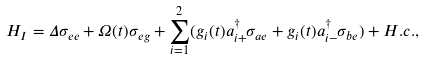Convert formula to latex. <formula><loc_0><loc_0><loc_500><loc_500>H _ { I } = \Delta \sigma _ { e e } + \Omega ( t ) \sigma _ { e g } + \sum _ { i = 1 } ^ { 2 } ( g _ { i } ( t ) a _ { i + } ^ { \dag } \sigma _ { a e } + g _ { i } ( t ) a _ { i - } ^ { \dag } \sigma _ { b e } ) + H . c . ,</formula> 